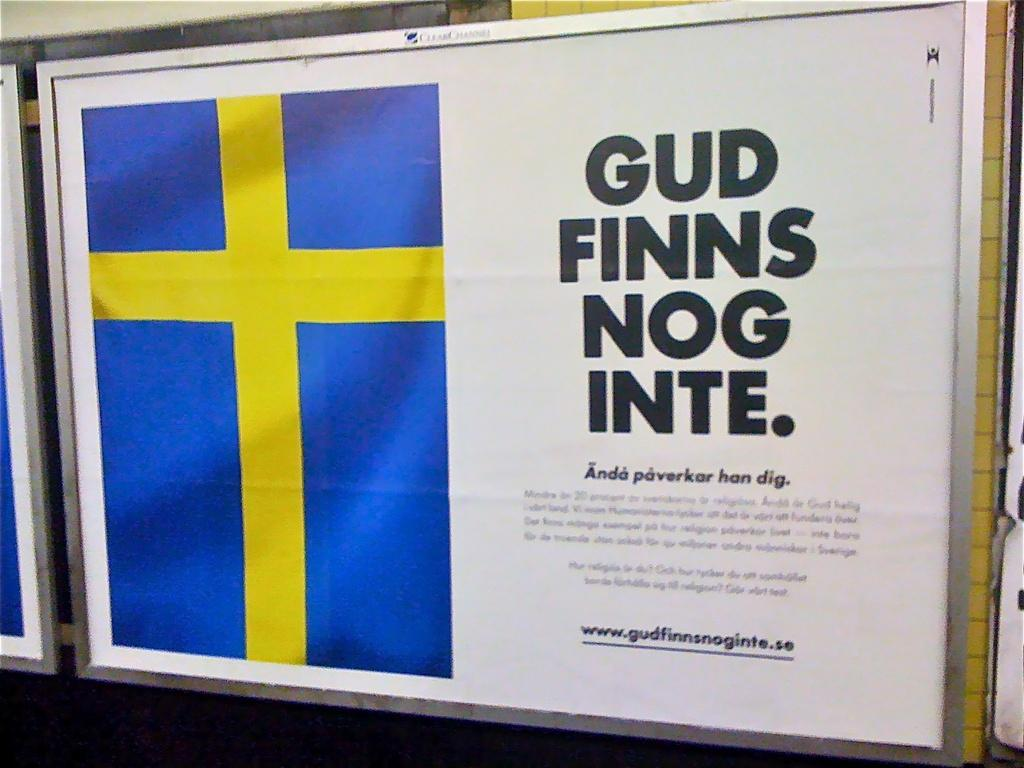What is the main object in the image? There is a poster in the image. What is depicted on the poster? There is a flag on the poster. Are there any words or letters on the poster? Yes, there is text on the poster. Does the poster express any feelings of regret in the image? There is no indication of regret in the image, as the poster only features a flag and text. 